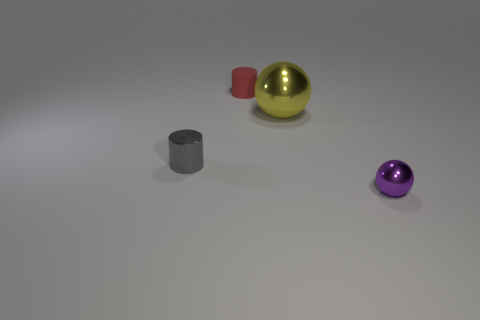Add 4 tiny purple metal balls. How many objects exist? 8 Add 2 small purple spheres. How many small purple spheres are left? 3 Add 1 gray objects. How many gray objects exist? 2 Subtract 0 green cubes. How many objects are left? 4 Subtract all blue metallic balls. Subtract all shiny things. How many objects are left? 1 